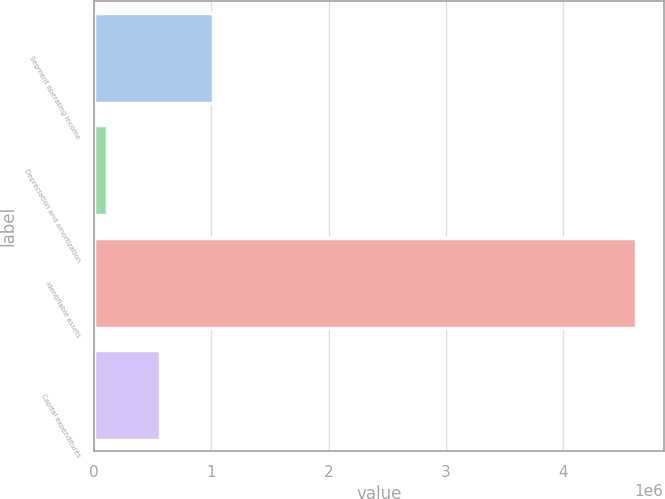Convert chart. <chart><loc_0><loc_0><loc_500><loc_500><bar_chart><fcel>Segment operating income<fcel>Depreciation and amortization<fcel>Identifiable assets<fcel>Capital expenditures<nl><fcel>1.01057e+06<fcel>107561<fcel>4.62261e+06<fcel>559066<nl></chart> 